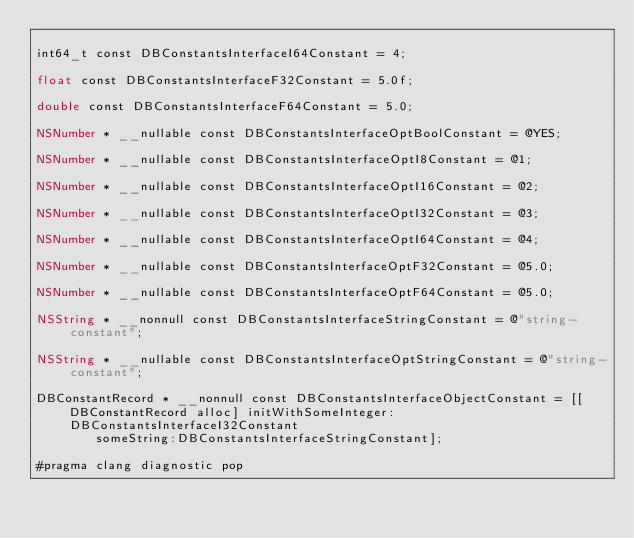<code> <loc_0><loc_0><loc_500><loc_500><_ObjectiveC_>
int64_t const DBConstantsInterfaceI64Constant = 4;

float const DBConstantsInterfaceF32Constant = 5.0f;

double const DBConstantsInterfaceF64Constant = 5.0;

NSNumber * __nullable const DBConstantsInterfaceOptBoolConstant = @YES;

NSNumber * __nullable const DBConstantsInterfaceOptI8Constant = @1;

NSNumber * __nullable const DBConstantsInterfaceOptI16Constant = @2;

NSNumber * __nullable const DBConstantsInterfaceOptI32Constant = @3;

NSNumber * __nullable const DBConstantsInterfaceOptI64Constant = @4;

NSNumber * __nullable const DBConstantsInterfaceOptF32Constant = @5.0;

NSNumber * __nullable const DBConstantsInterfaceOptF64Constant = @5.0;

NSString * __nonnull const DBConstantsInterfaceStringConstant = @"string-constant";

NSString * __nullable const DBConstantsInterfaceOptStringConstant = @"string-constant";

DBConstantRecord * __nonnull const DBConstantsInterfaceObjectConstant = [[DBConstantRecord alloc] initWithSomeInteger:DBConstantsInterfaceI32Constant
        someString:DBConstantsInterfaceStringConstant];

#pragma clang diagnostic pop
</code> 